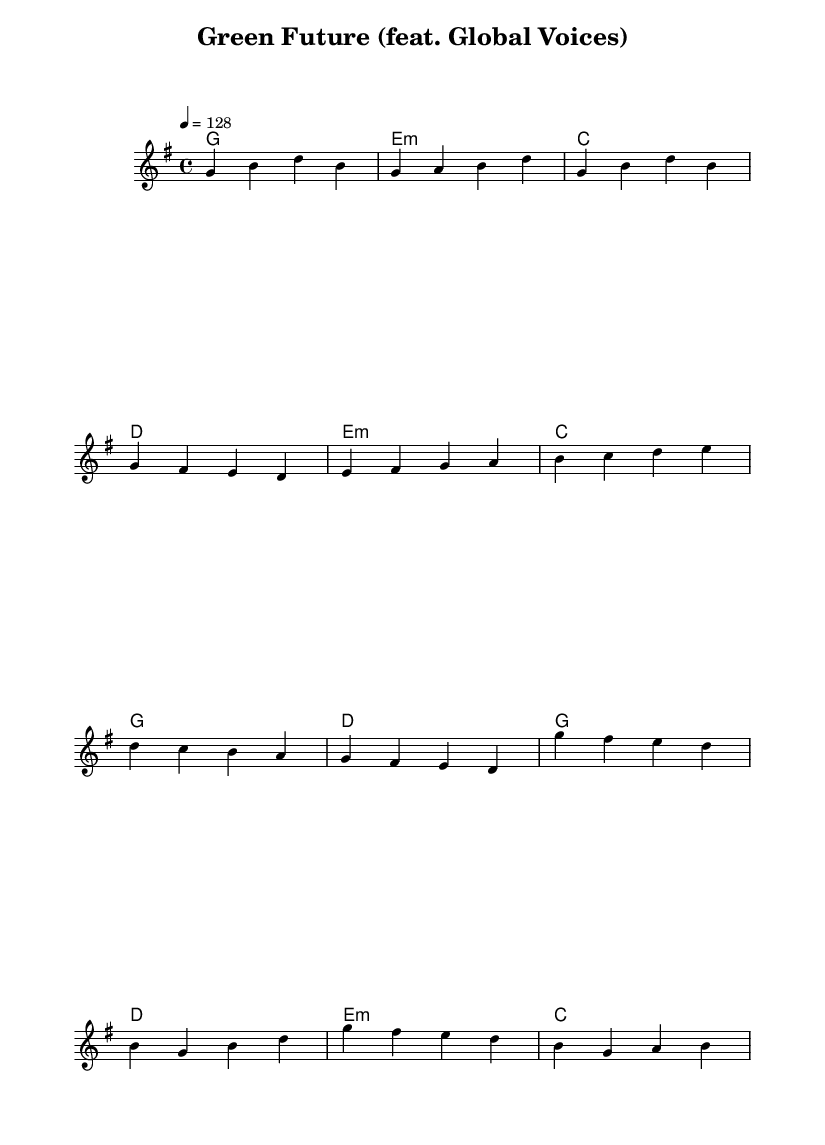What is the key signature of this music? The key signature is G major, indicated by an F# in the sheet music. This is deduced from the presence of the sharp symbol next to the F note at the beginning of the score.
Answer: G major What is the time signature of this music? The time signature is 4/4, as shown at the beginning of the piece, indicating four beats per measure. Each measure has four quarter note beats.
Answer: 4/4 What is the tempo marking of this music? The tempo marking is 128 beats per minute, which guides the performer to play at a relatively moderate speed. This is explicitly stated in the score with "4 = 128."
Answer: 128 What chords are used in the pre-chorus section? The chords in the pre-chorus section are E minor, C major, G major, and D major as listed in the harmonic progression. This requires looking at the chord mode lines during that section of the score.
Answer: E minor, C, G, D What is the structure of the song? The song follows a common ABA structure, starting with a verse, leading to a pre-chorus, and then a chorus. The labels of the musical sections guide us through the form clearly.
Answer: Verse, Pre-Chorus, Chorus How many unique chords are used throughout the music? There are four unique chords identified in the harmonies: G major, E minor, C major, and D major. Counting the distinct chords shown in the chord progression confirms this.
Answer: Four What element in K-Pop is prominent in this piece? The prominent element in this K-Pop piece is the collaboration aspect, emphasized by the title "feat. Global Voices," indicating inclusion of various international artists. This is a common characteristic in K-Pop songs that feature global themes or messages.
Answer: Collaboration 